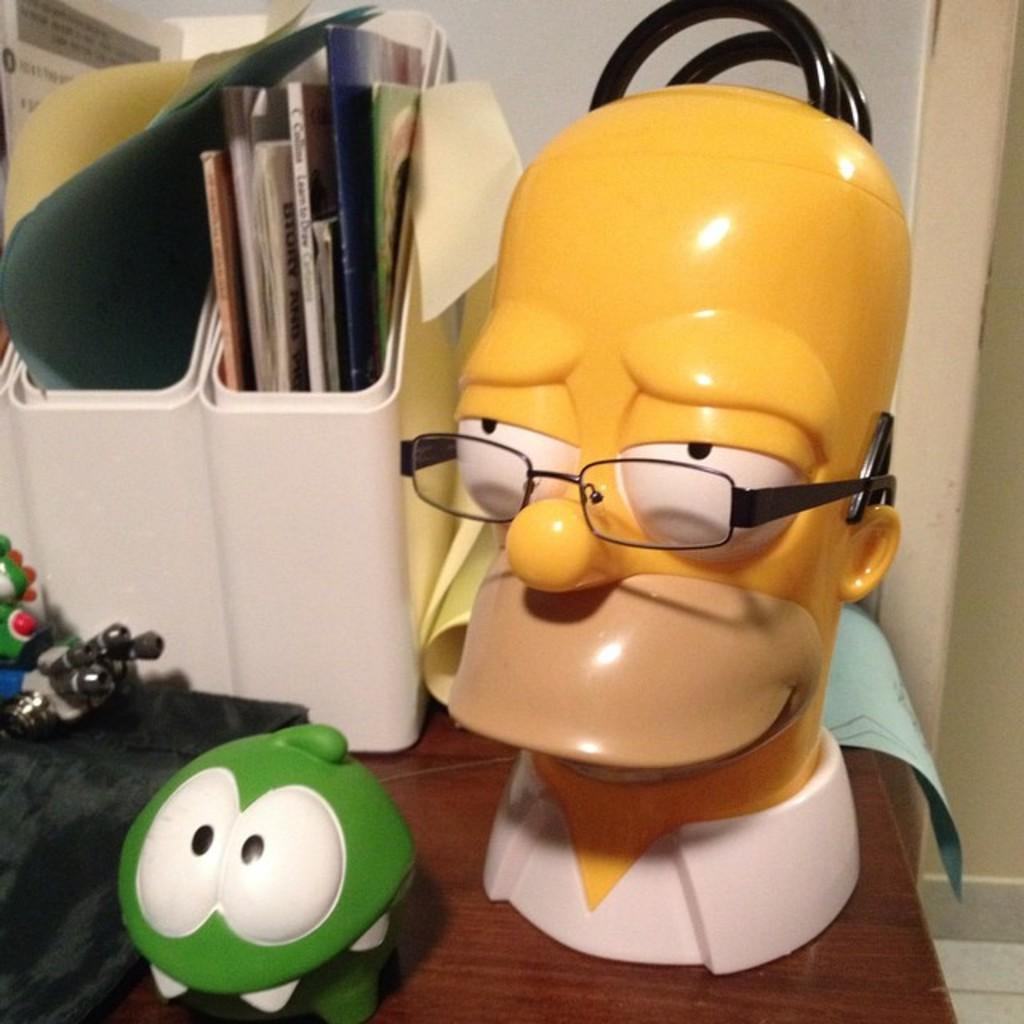What type of surface is visible in the image? There is a wooden surface in the image. What is placed on the wooden surface? There are toys on the wooden surface. Can you describe one of the toys in the image? One of the toys has specs on it. What else can be seen in the image besides the wooden surface and toys? There is a box with books in the image. What type of waste is visible in the image? There is no waste visible in the image. How many steps are there in the image? There is no mention of steps in the image. 